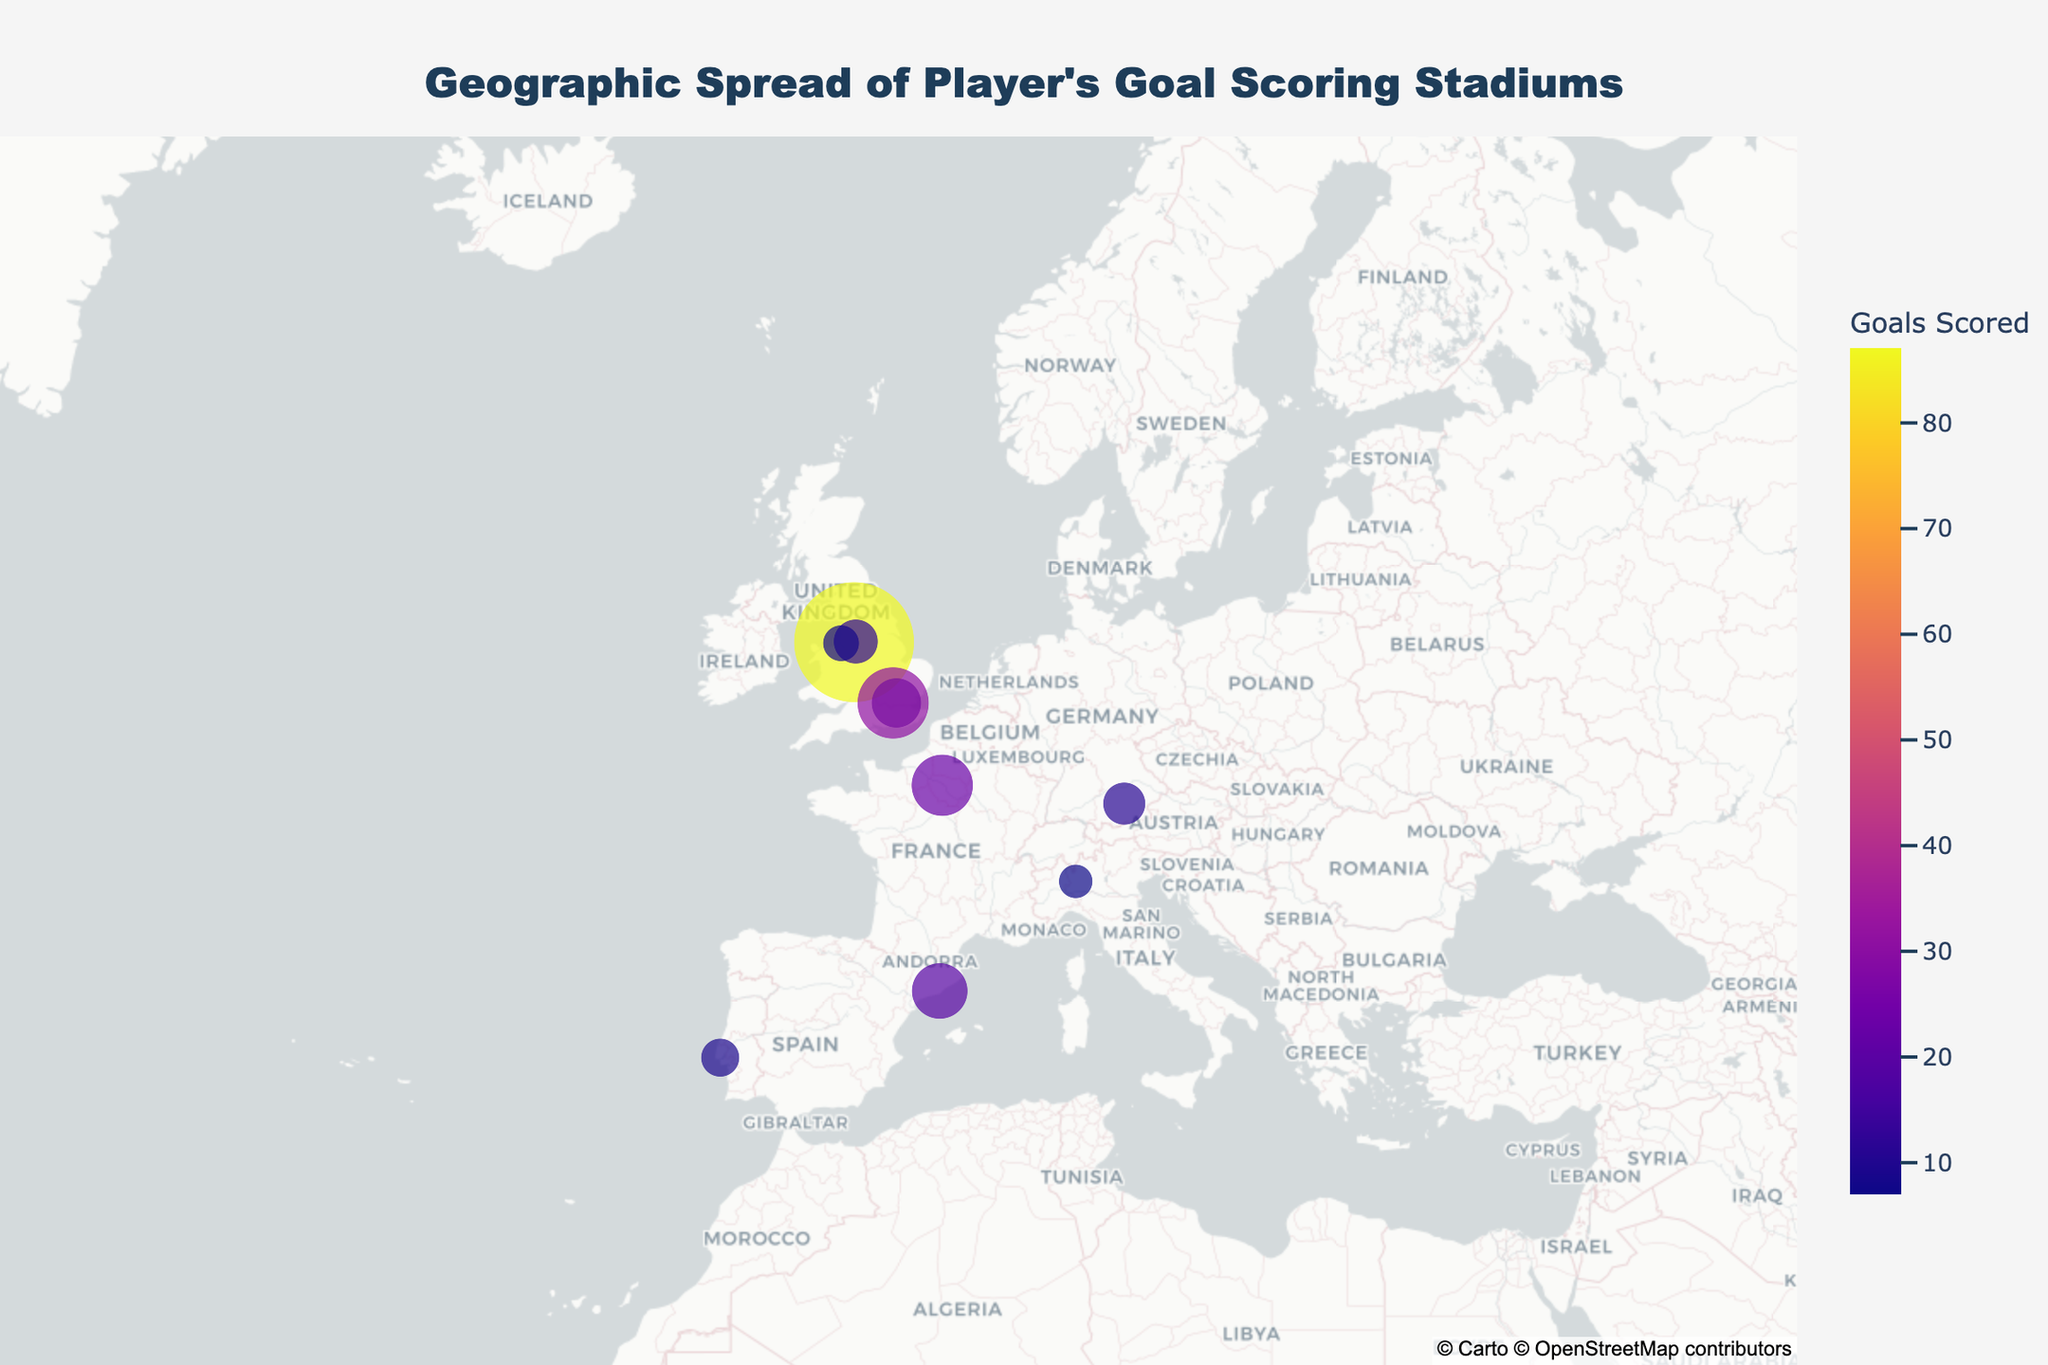How many countries are represented in the plot? Examine the countries listed in the hover data or visually distinguish the different geographic regions marked on the map. Count the unique entries for "Country".
Answer: 6 Which stadium has the highest number of goals scored? How many goals were scored there? By examining the sizes and colors (indicating the number of goals), identify the largest and most intensely colored marker. Hover over it or check the list to confirm the exact number.
Answer: Old Trafford, 87 What is the total number of goals scored in all the stadiums combined? Add the goals scored at each stadium: 87 + 12 + 8 + 15 + 23 + 19 + 11 + 7 + 9 + 31.
Answer: 222 How many stadiums in England have goals scored? Count the number of stadiums located in various cities within England by examining the hover data or locations marked as parts of the UK region.
Answer: 4 Which city has more goals scored, London or Manchester? Compare the total goals scored in stadiums within each city: London (Emirates Stadium and Wembley Stadium) and Manchester (Old Trafford and Etihad Stadium).
Answer: Manchester What is the average number of goals scored per stadium? Calculate the average by dividing the total number of goals by the number of stadiums. Total goals = 222, number of stadiums = 10.
Answer: 22.2 Which stadium outside England has the highest number of goals scored? Look at the stadiums located outside England (France, Spain, Germany, Italy, Portugal) and identify the one with the highest number of goals.
Answer: Parc des Princes Are there more goals scored in stadiums in England or in other countries combined? Sum the goals scored in English stadiums and compare it to the sum of the goals scored in stadiums located outside England. England: 87 + 12 + 8 + 15 + 31. Other countries: 23 + 19 + 11 + 7 + 9.
Answer: England What is the geographical center (latitude and longitude) of the stadiums? Estimate the average latitude and longitude of all the stadiums listed by summing their latitudes and longitudes and dividing each by the number of stadiums.
Answer: 47.45858, 0.01314 